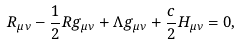Convert formula to latex. <formula><loc_0><loc_0><loc_500><loc_500>R _ { \mu \nu } - \frac { 1 } { 2 } R g _ { \mu \nu } + \Lambda g _ { \mu \nu } + \frac { c } { 2 } H _ { \mu \nu } = 0 ,</formula> 